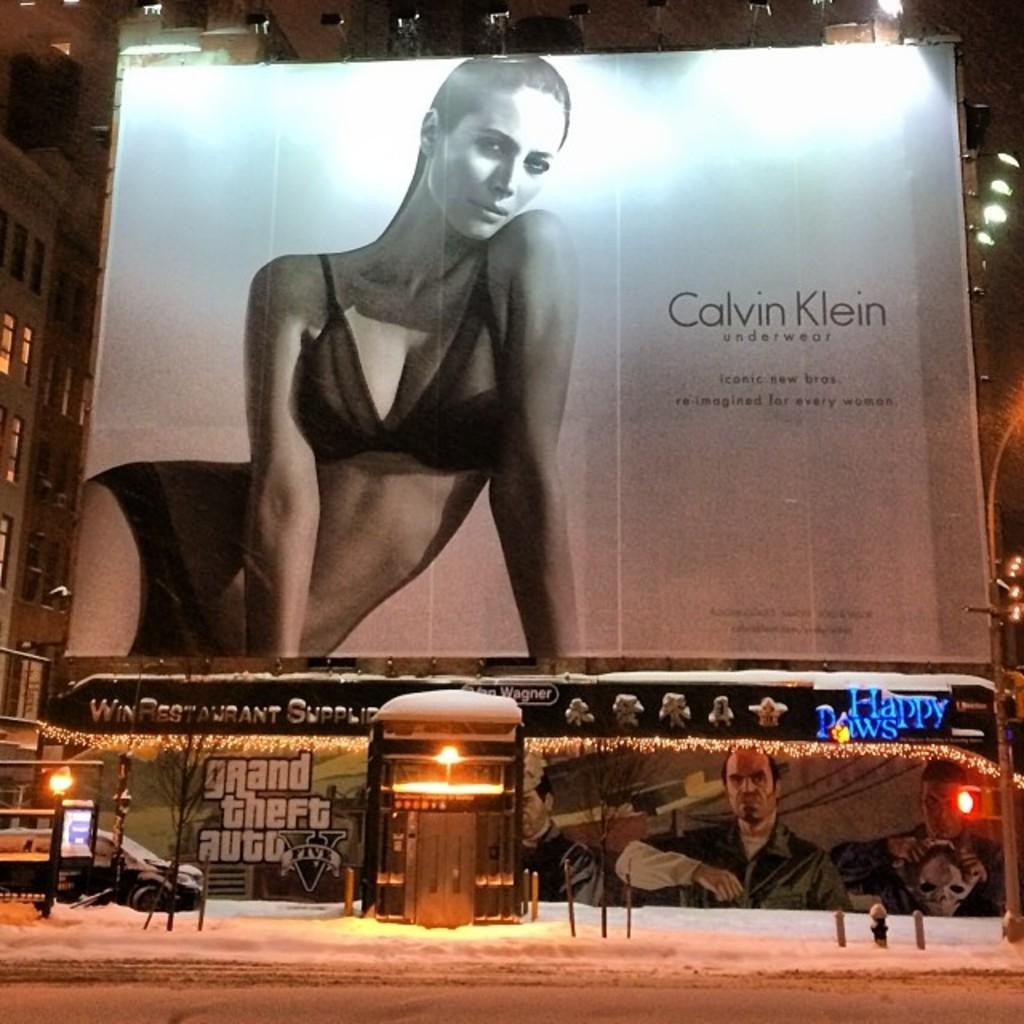Provide a one-sentence caption for the provided image. A Calvin Klein underwear billboard sits over an advertisement for Grand Theft Auto five. 